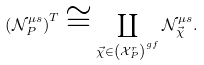<formula> <loc_0><loc_0><loc_500><loc_500>\left ( \mathcal { N } _ { P } ^ { \mu s } \right ) ^ { T } \cong \coprod _ { \vec { \chi } \in \left ( \mathcal { X } _ { P } ^ { r } \right ) ^ { g f } } \mathcal { N } _ { \vec { \chi } } ^ { \mu s } .</formula> 